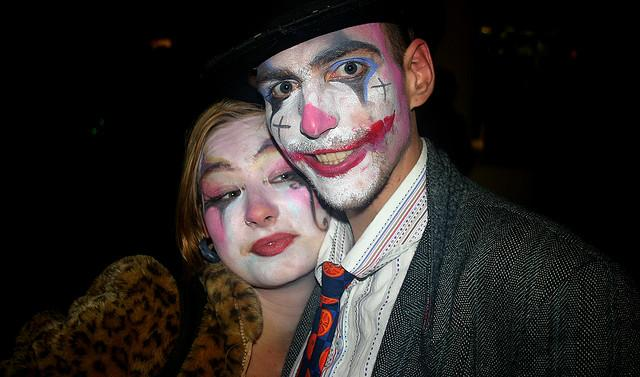What is the red thing near the man's mouth?

Choices:
A) paint
B) beet juice
C) blood
D) ketchup paint 